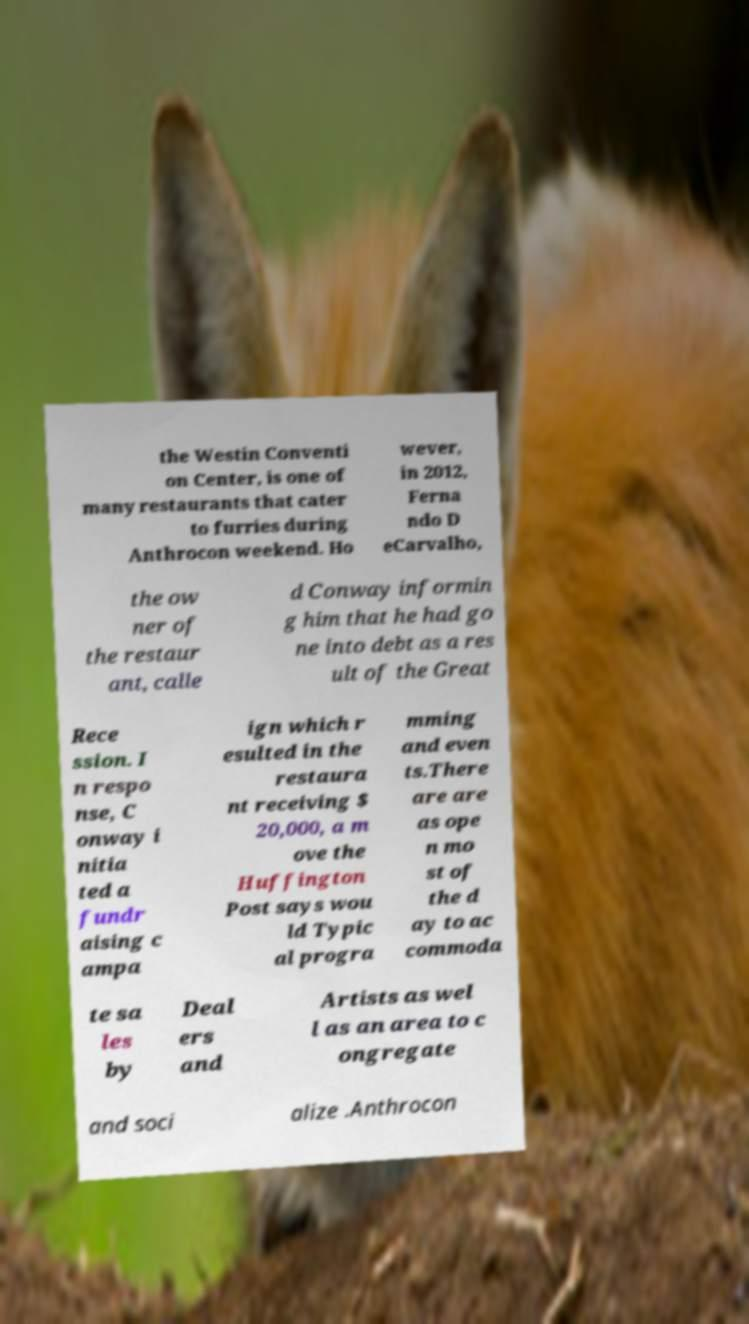Could you extract and type out the text from this image? the Westin Conventi on Center, is one of many restaurants that cater to furries during Anthrocon weekend. Ho wever, in 2012, Ferna ndo D eCarvalho, the ow ner of the restaur ant, calle d Conway informin g him that he had go ne into debt as a res ult of the Great Rece ssion. I n respo nse, C onway i nitia ted a fundr aising c ampa ign which r esulted in the restaura nt receiving $ 20,000, a m ove the Huffington Post says wou ld Typic al progra mming and even ts.There are are as ope n mo st of the d ay to ac commoda te sa les by Deal ers and Artists as wel l as an area to c ongregate and soci alize .Anthrocon 